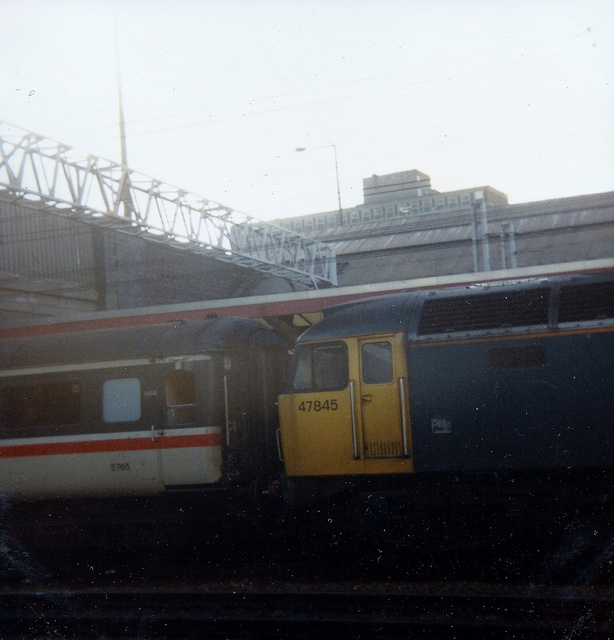Describe the objects in this image and their specific colors. I can see train in white, black, gray, olive, and maroon tones and train in white, black, gray, and maroon tones in this image. 